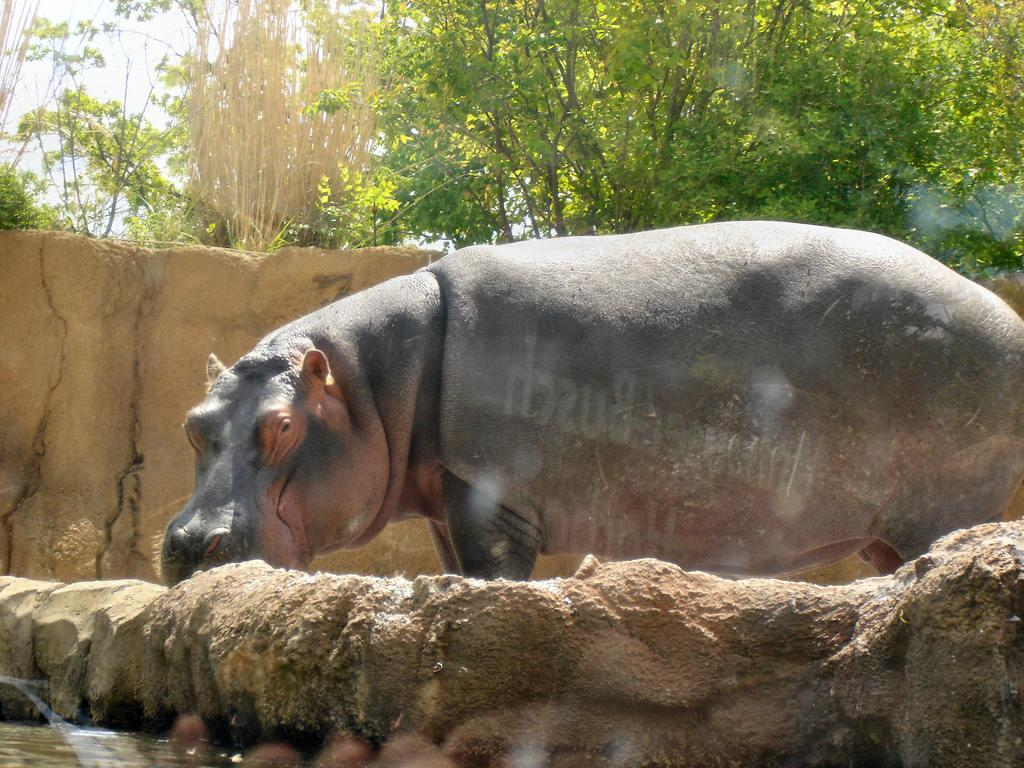What animal is the main subject of the image? There is a hippopotamus in the image. What is the hippopotamus doing in the image? The hippopotamus is standing in the image. What can be seen at the left bottom of the image? There is water at the left bottom of the image. What is visible in the background of the image? There are trees in the background of the image. What type of iron is being used by the hippopotamus in the image? There is no iron present in the image; it features a hippopotamus standing near water with trees in the background. 